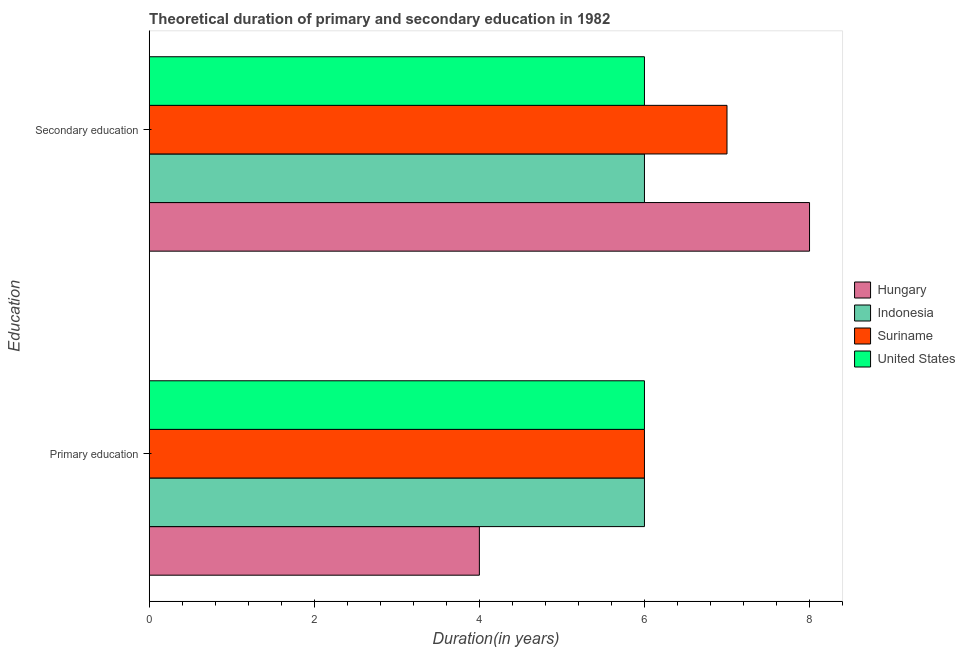How many bars are there on the 1st tick from the top?
Provide a succinct answer. 4. How many bars are there on the 2nd tick from the bottom?
Offer a very short reply. 4. Across all countries, what is the maximum duration of secondary education?
Offer a very short reply. 8. In which country was the duration of secondary education maximum?
Provide a succinct answer. Hungary. In which country was the duration of primary education minimum?
Ensure brevity in your answer.  Hungary. What is the total duration of secondary education in the graph?
Keep it short and to the point. 27. What is the difference between the duration of primary education in Suriname and that in Hungary?
Give a very brief answer. 2. What is the difference between the duration of primary education in Suriname and the duration of secondary education in Hungary?
Your response must be concise. -2. What is the average duration of secondary education per country?
Provide a short and direct response. 6.75. What does the 1st bar from the top in Secondary education represents?
Your answer should be very brief. United States. What does the 3rd bar from the bottom in Primary education represents?
Offer a very short reply. Suriname. How many bars are there?
Offer a very short reply. 8. How many countries are there in the graph?
Provide a short and direct response. 4. What is the difference between two consecutive major ticks on the X-axis?
Offer a very short reply. 2. Are the values on the major ticks of X-axis written in scientific E-notation?
Offer a terse response. No. Does the graph contain any zero values?
Keep it short and to the point. No. Does the graph contain grids?
Provide a short and direct response. No. Where does the legend appear in the graph?
Your response must be concise. Center right. How are the legend labels stacked?
Provide a succinct answer. Vertical. What is the title of the graph?
Provide a short and direct response. Theoretical duration of primary and secondary education in 1982. What is the label or title of the X-axis?
Provide a succinct answer. Duration(in years). What is the label or title of the Y-axis?
Offer a very short reply. Education. What is the Duration(in years) of Hungary in Primary education?
Make the answer very short. 4. What is the Duration(in years) of United States in Primary education?
Offer a terse response. 6. What is the Duration(in years) in Hungary in Secondary education?
Your answer should be very brief. 8. What is the Duration(in years) in Suriname in Secondary education?
Provide a short and direct response. 7. Across all Education, what is the maximum Duration(in years) in Hungary?
Provide a succinct answer. 8. Across all Education, what is the maximum Duration(in years) in Indonesia?
Your answer should be compact. 6. Across all Education, what is the maximum Duration(in years) of Suriname?
Offer a terse response. 7. Across all Education, what is the maximum Duration(in years) of United States?
Make the answer very short. 6. Across all Education, what is the minimum Duration(in years) in Hungary?
Your response must be concise. 4. Across all Education, what is the minimum Duration(in years) in Indonesia?
Offer a terse response. 6. Across all Education, what is the minimum Duration(in years) in United States?
Provide a short and direct response. 6. What is the total Duration(in years) of Hungary in the graph?
Ensure brevity in your answer.  12. What is the difference between the Duration(in years) in Hungary in Primary education and that in Secondary education?
Give a very brief answer. -4. What is the difference between the Duration(in years) of Suriname in Primary education and that in Secondary education?
Your answer should be compact. -1. What is the difference between the Duration(in years) of Hungary in Primary education and the Duration(in years) of Indonesia in Secondary education?
Give a very brief answer. -2. What is the difference between the Duration(in years) of Hungary in Primary education and the Duration(in years) of Suriname in Secondary education?
Provide a short and direct response. -3. What is the average Duration(in years) of Hungary per Education?
Ensure brevity in your answer.  6. What is the average Duration(in years) in United States per Education?
Provide a succinct answer. 6. What is the difference between the Duration(in years) of Hungary and Duration(in years) of Suriname in Primary education?
Your answer should be compact. -2. What is the difference between the Duration(in years) of Hungary and Duration(in years) of United States in Primary education?
Provide a short and direct response. -2. What is the difference between the Duration(in years) in Indonesia and Duration(in years) in United States in Primary education?
Ensure brevity in your answer.  0. What is the difference between the Duration(in years) of Hungary and Duration(in years) of Suriname in Secondary education?
Keep it short and to the point. 1. What is the difference between the Duration(in years) of Hungary and Duration(in years) of United States in Secondary education?
Provide a short and direct response. 2. What is the difference between the Duration(in years) of Indonesia and Duration(in years) of Suriname in Secondary education?
Ensure brevity in your answer.  -1. What is the ratio of the Duration(in years) in Hungary in Primary education to that in Secondary education?
Keep it short and to the point. 0.5. What is the ratio of the Duration(in years) in Indonesia in Primary education to that in Secondary education?
Provide a succinct answer. 1. What is the ratio of the Duration(in years) in Suriname in Primary education to that in Secondary education?
Provide a short and direct response. 0.86. What is the ratio of the Duration(in years) of United States in Primary education to that in Secondary education?
Your answer should be compact. 1. What is the difference between the highest and the second highest Duration(in years) in Indonesia?
Your answer should be very brief. 0. What is the difference between the highest and the second highest Duration(in years) of Suriname?
Your answer should be very brief. 1. What is the difference between the highest and the lowest Duration(in years) in Hungary?
Offer a very short reply. 4. What is the difference between the highest and the lowest Duration(in years) of Suriname?
Ensure brevity in your answer.  1. What is the difference between the highest and the lowest Duration(in years) in United States?
Offer a terse response. 0. 